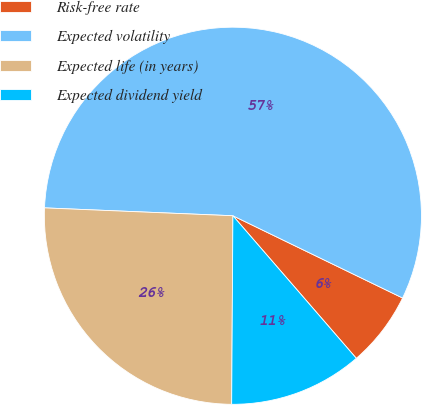Convert chart to OTSL. <chart><loc_0><loc_0><loc_500><loc_500><pie_chart><fcel>Risk-free rate<fcel>Expected volatility<fcel>Expected life (in years)<fcel>Expected dividend yield<nl><fcel>6.46%<fcel>56.52%<fcel>25.56%<fcel>11.46%<nl></chart> 